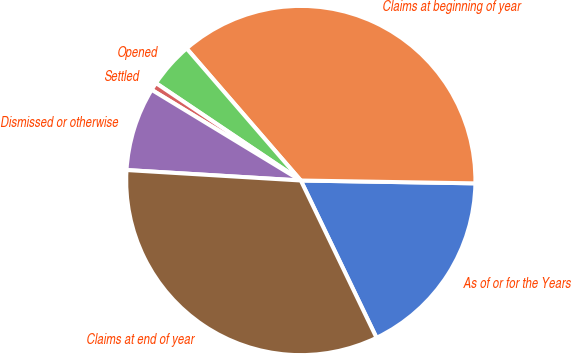Convert chart. <chart><loc_0><loc_0><loc_500><loc_500><pie_chart><fcel>As of or for the Years<fcel>Claims at beginning of year<fcel>Opened<fcel>Settled<fcel>Dismissed or otherwise<fcel>Claims at end of year<nl><fcel>17.6%<fcel>36.61%<fcel>4.23%<fcel>0.73%<fcel>7.74%<fcel>33.1%<nl></chart> 